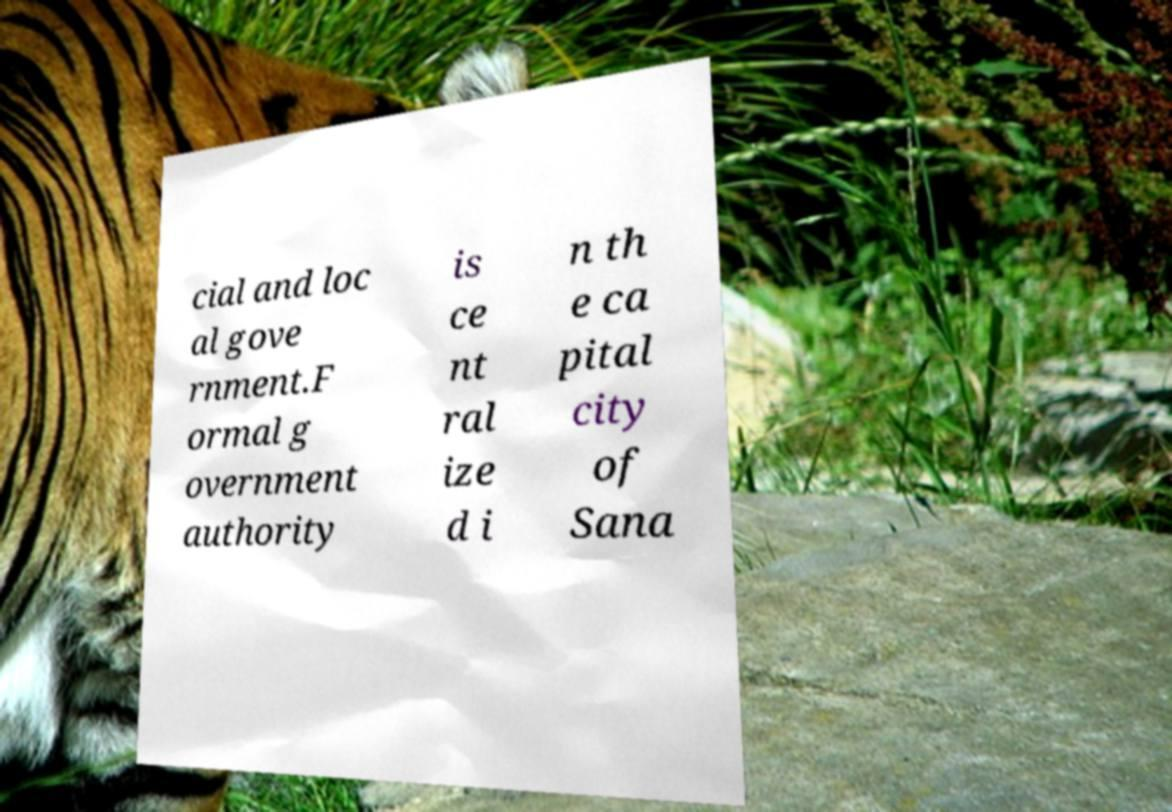Can you accurately transcribe the text from the provided image for me? cial and loc al gove rnment.F ormal g overnment authority is ce nt ral ize d i n th e ca pital city of Sana 